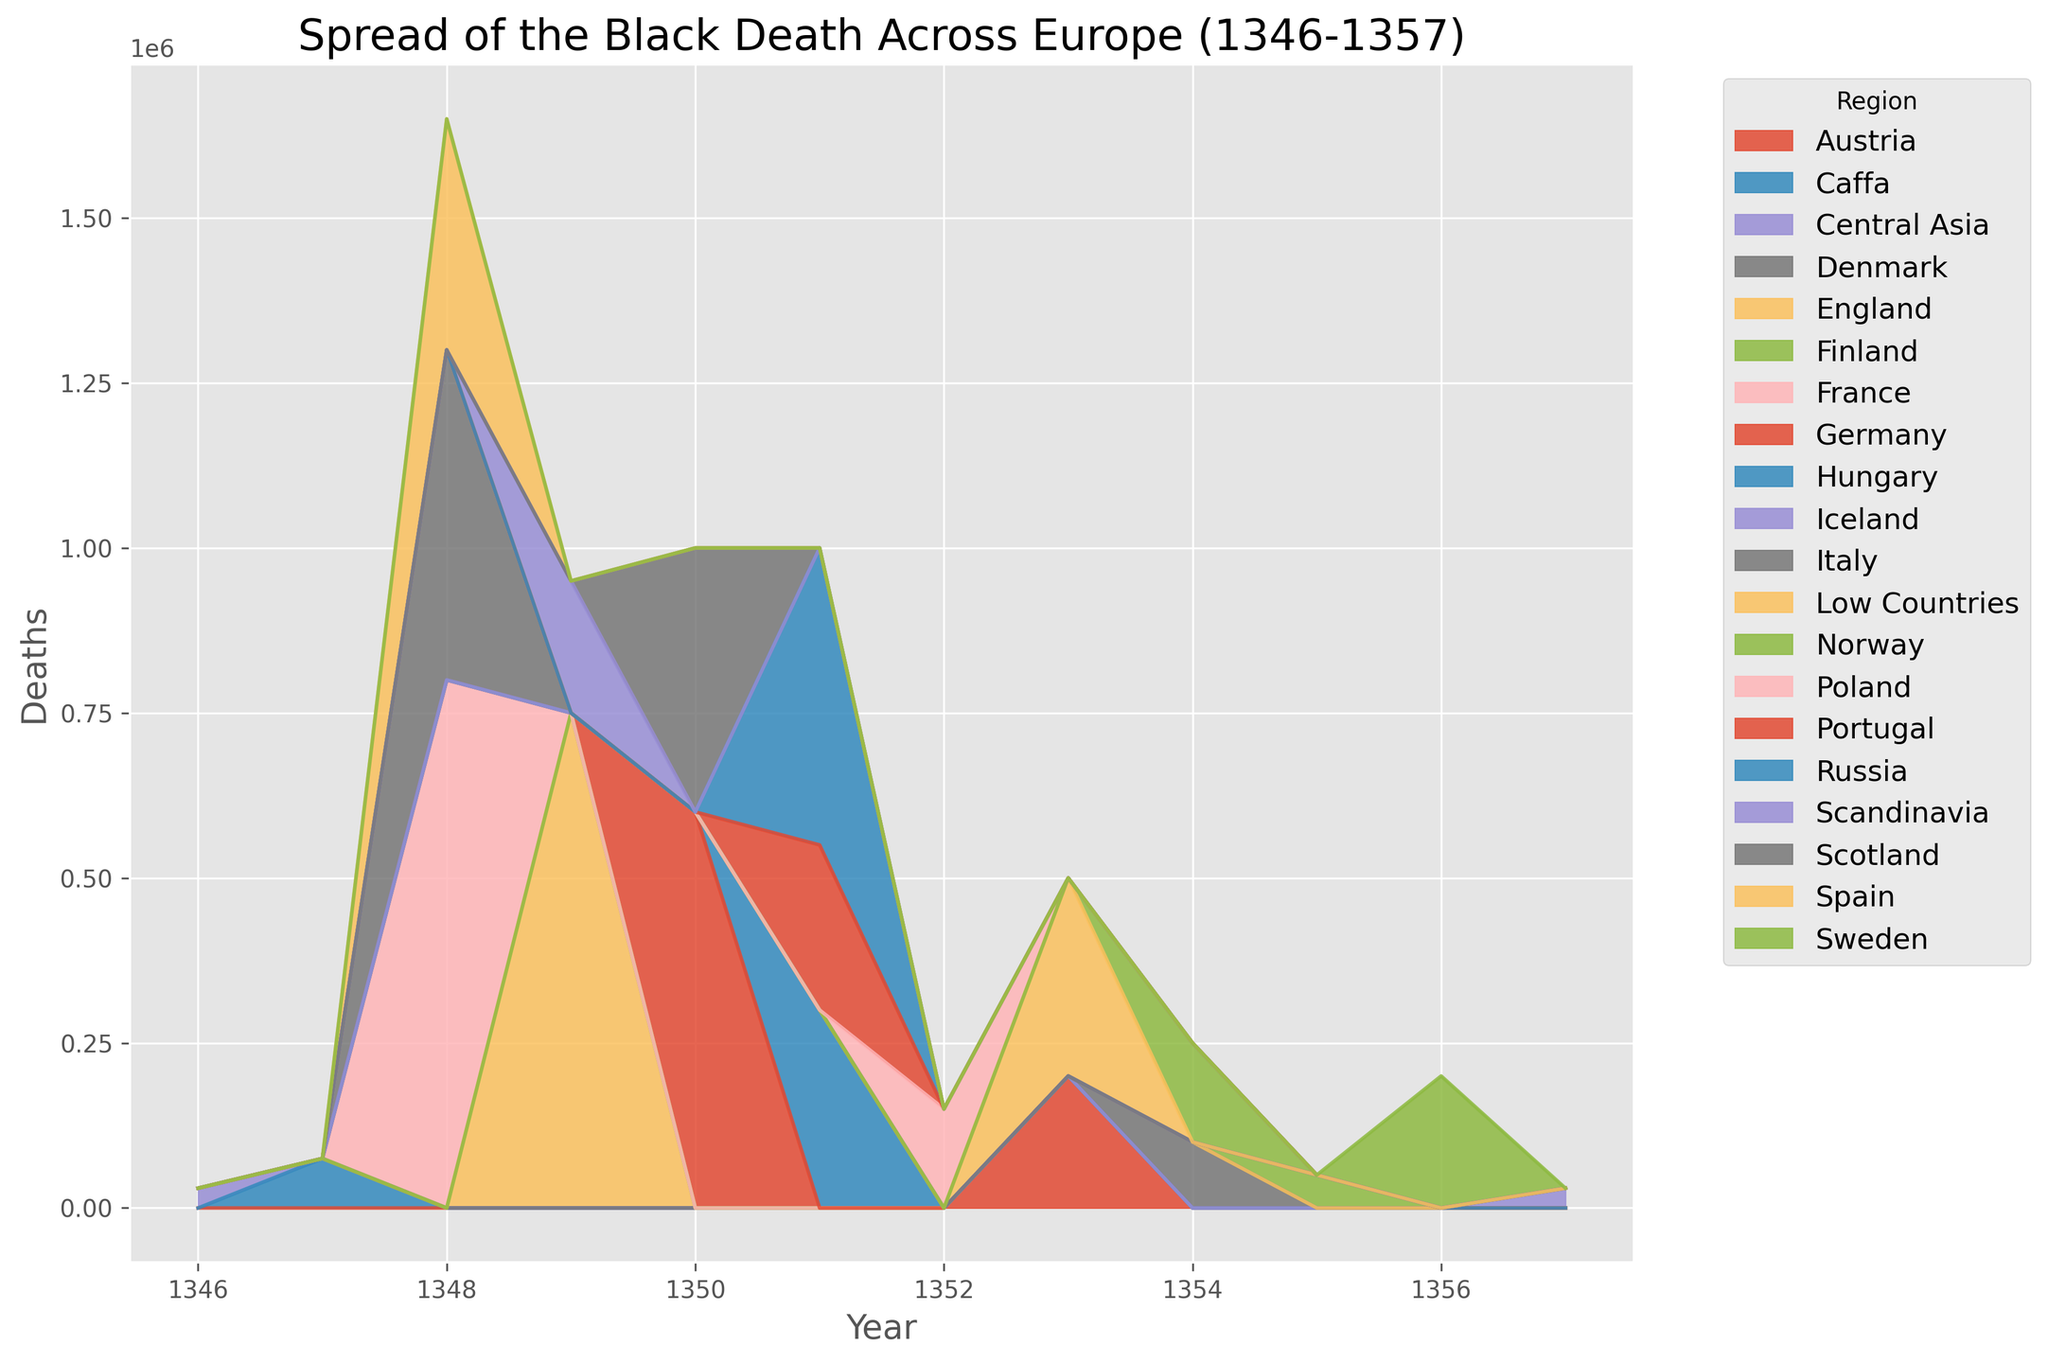Which region experienced the highest number of deaths in 1348? Looking at the chart for the year 1348, identify the region with the largest area, indicating the highest number of deaths.
Answer: France Which year had the most widespread number of regions affected? By visually inspecting the number of different-colored areas stacked within each year along the x-axis, you can see which year has the most regions represented.
Answer: 1351 How many total deaths occurred in the years 1349 and 1350 combined? Sum the vertical heights (death counts) of all regions displayed for the years 1349 and 1350 from the chart.
Answer: 1,950,000 In which year did Italy experience the highest number of deaths? Locate Italy's colored area across the years and identify which year shows Italy's area reaching its maximum height.
Answer: 1348 Compare the deaths between England and Spain in 1349. Which country had more deaths that year? Identify the respective heights of England's and Spain's regions for the year 1349 and compare their areas.
Answer: England had more deaths Which of the Scandinavian countries (Denmark, Norway, Sweden) had the lowest death toll, and in what year did this occur? Examine the colored areas corresponding to Denmark, Norway, and Sweden. Note the heights and identify the country and year with the lowest area.
Answer: Denmark in 1354 What was the total number of deaths in Central Asia and Russia combined over the entire period? Sum the areas corresponding to Central Asia and Russia across all years in the chart.
Answer: 480,000 In which years did the Black Death reach the Low Countries and Austria? Look for the appearance of colored areas representing Low Countries and Austria across the years on the chart.
Answer: 1353 What color is used to represent the deaths in Iceland, and what is the size of its corresponding area? Identify the visual attribute (color) used for Iceland in the chart and observe the area size for Iceland's deaths data.
Answer: The color used is specific and the area size is the result interpreted from the chart; color: to be specified from the chart How does the number of deaths in Scotland in 1350 compare to those in Hungary in 1351? Locate the death counts (area heights) for Scotland in 1350 and Hungary in 1351, then compare these two values.
Answer: Hungary had more deaths 